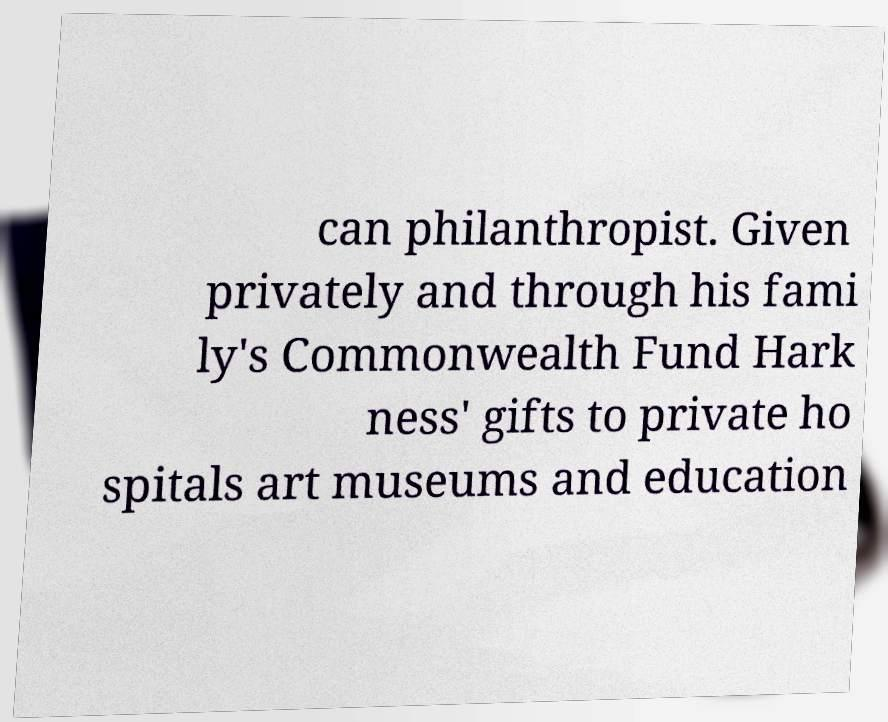Could you assist in decoding the text presented in this image and type it out clearly? can philanthropist. Given privately and through his fami ly's Commonwealth Fund Hark ness' gifts to private ho spitals art museums and education 